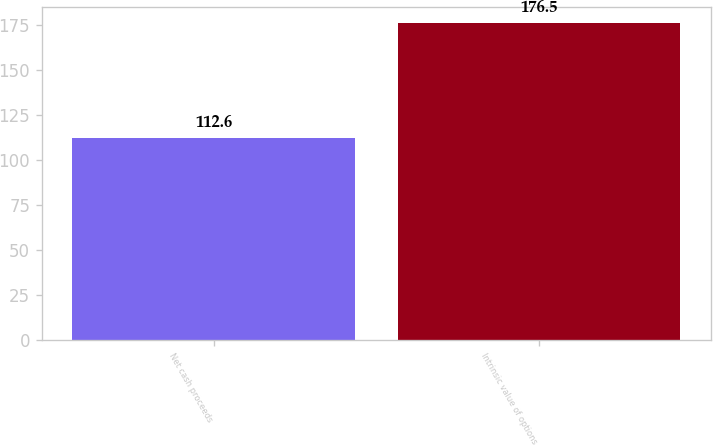<chart> <loc_0><loc_0><loc_500><loc_500><bar_chart><fcel>Net cash proceeds<fcel>Intrinsic value of options<nl><fcel>112.6<fcel>176.5<nl></chart> 